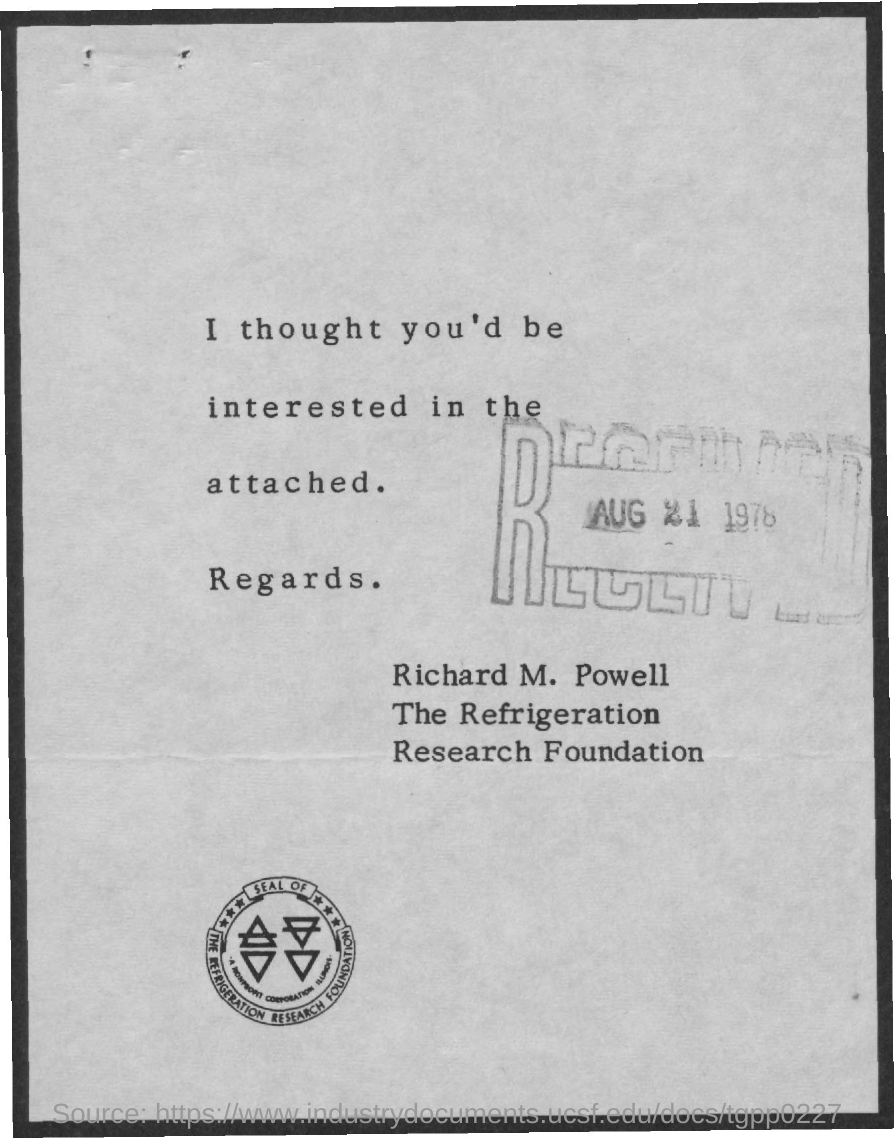What is the month and day on the "RECEIVED" stamp?
Your response must be concise. AUG 21. Who is this letter from?
Your response must be concise. Richard M. Powell. 